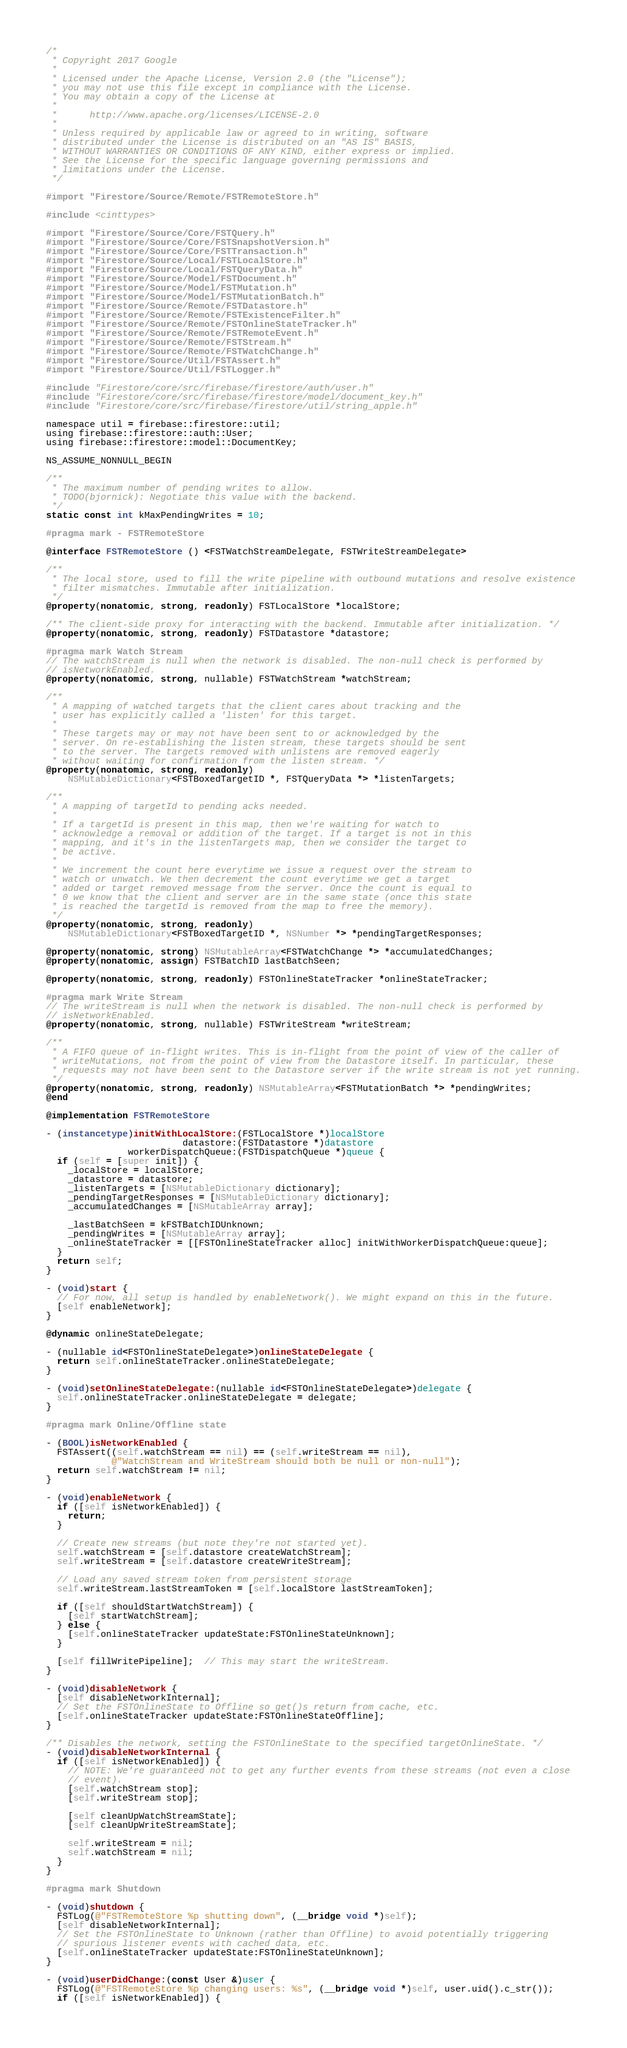<code> <loc_0><loc_0><loc_500><loc_500><_ObjectiveC_>/*
 * Copyright 2017 Google
 *
 * Licensed under the Apache License, Version 2.0 (the "License");
 * you may not use this file except in compliance with the License.
 * You may obtain a copy of the License at
 *
 *      http://www.apache.org/licenses/LICENSE-2.0
 *
 * Unless required by applicable law or agreed to in writing, software
 * distributed under the License is distributed on an "AS IS" BASIS,
 * WITHOUT WARRANTIES OR CONDITIONS OF ANY KIND, either express or implied.
 * See the License for the specific language governing permissions and
 * limitations under the License.
 */

#import "Firestore/Source/Remote/FSTRemoteStore.h"

#include <cinttypes>

#import "Firestore/Source/Core/FSTQuery.h"
#import "Firestore/Source/Core/FSTSnapshotVersion.h"
#import "Firestore/Source/Core/FSTTransaction.h"
#import "Firestore/Source/Local/FSTLocalStore.h"
#import "Firestore/Source/Local/FSTQueryData.h"
#import "Firestore/Source/Model/FSTDocument.h"
#import "Firestore/Source/Model/FSTMutation.h"
#import "Firestore/Source/Model/FSTMutationBatch.h"
#import "Firestore/Source/Remote/FSTDatastore.h"
#import "Firestore/Source/Remote/FSTExistenceFilter.h"
#import "Firestore/Source/Remote/FSTOnlineStateTracker.h"
#import "Firestore/Source/Remote/FSTRemoteEvent.h"
#import "Firestore/Source/Remote/FSTStream.h"
#import "Firestore/Source/Remote/FSTWatchChange.h"
#import "Firestore/Source/Util/FSTAssert.h"
#import "Firestore/Source/Util/FSTLogger.h"

#include "Firestore/core/src/firebase/firestore/auth/user.h"
#include "Firestore/core/src/firebase/firestore/model/document_key.h"
#include "Firestore/core/src/firebase/firestore/util/string_apple.h"

namespace util = firebase::firestore::util;
using firebase::firestore::auth::User;
using firebase::firestore::model::DocumentKey;

NS_ASSUME_NONNULL_BEGIN

/**
 * The maximum number of pending writes to allow.
 * TODO(bjornick): Negotiate this value with the backend.
 */
static const int kMaxPendingWrites = 10;

#pragma mark - FSTRemoteStore

@interface FSTRemoteStore () <FSTWatchStreamDelegate, FSTWriteStreamDelegate>

/**
 * The local store, used to fill the write pipeline with outbound mutations and resolve existence
 * filter mismatches. Immutable after initialization.
 */
@property(nonatomic, strong, readonly) FSTLocalStore *localStore;

/** The client-side proxy for interacting with the backend. Immutable after initialization. */
@property(nonatomic, strong, readonly) FSTDatastore *datastore;

#pragma mark Watch Stream
// The watchStream is null when the network is disabled. The non-null check is performed by
// isNetworkEnabled.
@property(nonatomic, strong, nullable) FSTWatchStream *watchStream;

/**
 * A mapping of watched targets that the client cares about tracking and the
 * user has explicitly called a 'listen' for this target.
 *
 * These targets may or may not have been sent to or acknowledged by the
 * server. On re-establishing the listen stream, these targets should be sent
 * to the server. The targets removed with unlistens are removed eagerly
 * without waiting for confirmation from the listen stream. */
@property(nonatomic, strong, readonly)
    NSMutableDictionary<FSTBoxedTargetID *, FSTQueryData *> *listenTargets;

/**
 * A mapping of targetId to pending acks needed.
 *
 * If a targetId is present in this map, then we're waiting for watch to
 * acknowledge a removal or addition of the target. If a target is not in this
 * mapping, and it's in the listenTargets map, then we consider the target to
 * be active.
 *
 * We increment the count here everytime we issue a request over the stream to
 * watch or unwatch. We then decrement the count everytime we get a target
 * added or target removed message from the server. Once the count is equal to
 * 0 we know that the client and server are in the same state (once this state
 * is reached the targetId is removed from the map to free the memory).
 */
@property(nonatomic, strong, readonly)
    NSMutableDictionary<FSTBoxedTargetID *, NSNumber *> *pendingTargetResponses;

@property(nonatomic, strong) NSMutableArray<FSTWatchChange *> *accumulatedChanges;
@property(nonatomic, assign) FSTBatchID lastBatchSeen;

@property(nonatomic, strong, readonly) FSTOnlineStateTracker *onlineStateTracker;

#pragma mark Write Stream
// The writeStream is null when the network is disabled. The non-null check is performed by
// isNetworkEnabled.
@property(nonatomic, strong, nullable) FSTWriteStream *writeStream;

/**
 * A FIFO queue of in-flight writes. This is in-flight from the point of view of the caller of
 * writeMutations, not from the point of view from the Datastore itself. In particular, these
 * requests may not have been sent to the Datastore server if the write stream is not yet running.
 */
@property(nonatomic, strong, readonly) NSMutableArray<FSTMutationBatch *> *pendingWrites;
@end

@implementation FSTRemoteStore

- (instancetype)initWithLocalStore:(FSTLocalStore *)localStore
                         datastore:(FSTDatastore *)datastore
               workerDispatchQueue:(FSTDispatchQueue *)queue {
  if (self = [super init]) {
    _localStore = localStore;
    _datastore = datastore;
    _listenTargets = [NSMutableDictionary dictionary];
    _pendingTargetResponses = [NSMutableDictionary dictionary];
    _accumulatedChanges = [NSMutableArray array];

    _lastBatchSeen = kFSTBatchIDUnknown;
    _pendingWrites = [NSMutableArray array];
    _onlineStateTracker = [[FSTOnlineStateTracker alloc] initWithWorkerDispatchQueue:queue];
  }
  return self;
}

- (void)start {
  // For now, all setup is handled by enableNetwork(). We might expand on this in the future.
  [self enableNetwork];
}

@dynamic onlineStateDelegate;

- (nullable id<FSTOnlineStateDelegate>)onlineStateDelegate {
  return self.onlineStateTracker.onlineStateDelegate;
}

- (void)setOnlineStateDelegate:(nullable id<FSTOnlineStateDelegate>)delegate {
  self.onlineStateTracker.onlineStateDelegate = delegate;
}

#pragma mark Online/Offline state

- (BOOL)isNetworkEnabled {
  FSTAssert((self.watchStream == nil) == (self.writeStream == nil),
            @"WatchStream and WriteStream should both be null or non-null");
  return self.watchStream != nil;
}

- (void)enableNetwork {
  if ([self isNetworkEnabled]) {
    return;
  }

  // Create new streams (but note they're not started yet).
  self.watchStream = [self.datastore createWatchStream];
  self.writeStream = [self.datastore createWriteStream];

  // Load any saved stream token from persistent storage
  self.writeStream.lastStreamToken = [self.localStore lastStreamToken];

  if ([self shouldStartWatchStream]) {
    [self startWatchStream];
  } else {
    [self.onlineStateTracker updateState:FSTOnlineStateUnknown];
  }

  [self fillWritePipeline];  // This may start the writeStream.
}

- (void)disableNetwork {
  [self disableNetworkInternal];
  // Set the FSTOnlineState to Offline so get()s return from cache, etc.
  [self.onlineStateTracker updateState:FSTOnlineStateOffline];
}

/** Disables the network, setting the FSTOnlineState to the specified targetOnlineState. */
- (void)disableNetworkInternal {
  if ([self isNetworkEnabled]) {
    // NOTE: We're guaranteed not to get any further events from these streams (not even a close
    // event).
    [self.watchStream stop];
    [self.writeStream stop];

    [self cleanUpWatchStreamState];
    [self cleanUpWriteStreamState];

    self.writeStream = nil;
    self.watchStream = nil;
  }
}

#pragma mark Shutdown

- (void)shutdown {
  FSTLog(@"FSTRemoteStore %p shutting down", (__bridge void *)self);
  [self disableNetworkInternal];
  // Set the FSTOnlineState to Unknown (rather than Offline) to avoid potentially triggering
  // spurious listener events with cached data, etc.
  [self.onlineStateTracker updateState:FSTOnlineStateUnknown];
}

- (void)userDidChange:(const User &)user {
  FSTLog(@"FSTRemoteStore %p changing users: %s", (__bridge void *)self, user.uid().c_str());
  if ([self isNetworkEnabled]) {</code> 